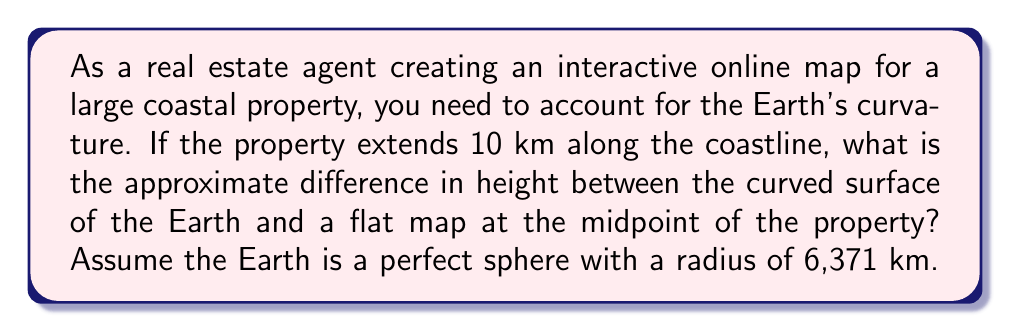Can you solve this math problem? To solve this problem, we need to consider the curvature of the Earth's surface. We can model this situation as a circular arc and compare it to its chord (the straight line on a flat map).

Let's approach this step-by-step:

1) First, we need to calculate the central angle $\theta$ (in radians) that corresponds to the 10 km arc length:

   $$\theta = \frac{arc length}{radius} = \frac{10}{6371} \approx 0.001569 \text{ radians}$$

2) Now, we can calculate the height of the arc at its midpoint. This is the difference between the radius and the distance from the center of the Earth to the midpoint of the chord.

3) The distance from the center to the midpoint of the chord can be calculated using the cosine function:

   $$d = R \cos(\frac{\theta}{2})$$

   Where $R$ is the Earth's radius and $\theta/2$ is half the central angle.

4) The height difference $h$ is then:

   $$h = R - d = R - R \cos(\frac{\theta}{2}) = R(1 - \cos(\frac{\theta}{2}))$$

5) Substituting the values:

   $$h = 6371(1 - \cos(\frac{0.001569}{2}))$$

6) Using a calculator or computer for precision:

   $$h \approx 6371 \times 0.0000000616 \approx 0.000392 \text{ km} = 0.392 \text{ m}$$

This result shows that for a 10 km stretch of coastline, the Earth's curvature causes a height difference of about 39.2 cm at the midpoint compared to a flat map.
Answer: The approximate difference in height between the curved surface of the Earth and a flat map at the midpoint of the 10 km property is 0.392 meters or 39.2 centimeters. 